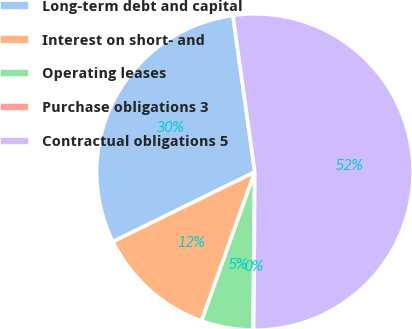Convert chart. <chart><loc_0><loc_0><loc_500><loc_500><pie_chart><fcel>Long-term debt and capital<fcel>Interest on short- and<fcel>Operating leases<fcel>Purchase obligations 3<fcel>Contractual obligations 5<nl><fcel>30.05%<fcel>12.26%<fcel>5.29%<fcel>0.07%<fcel>52.32%<nl></chart> 